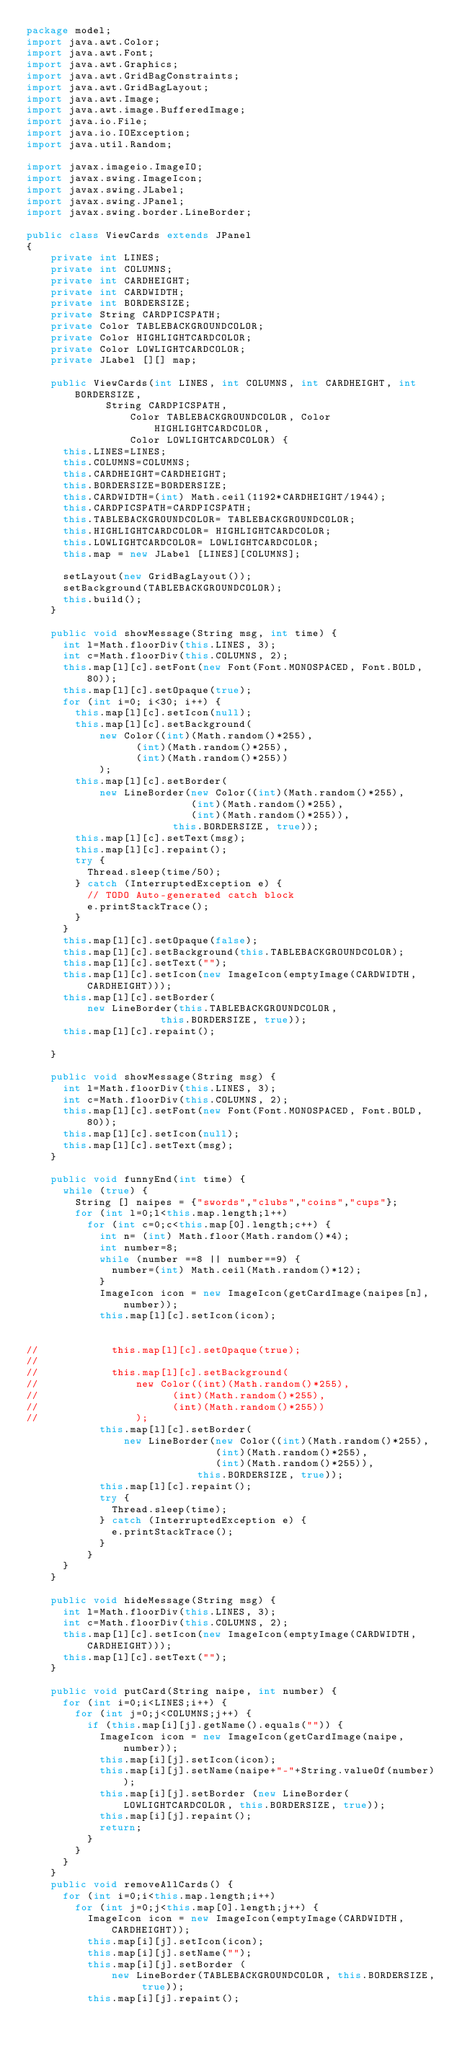Convert code to text. <code><loc_0><loc_0><loc_500><loc_500><_Java_>package model;
import java.awt.Color;
import java.awt.Font;
import java.awt.Graphics;
import java.awt.GridBagConstraints;
import java.awt.GridBagLayout;
import java.awt.Image;
import java.awt.image.BufferedImage;
import java.io.File;
import java.io.IOException;
import java.util.Random;

import javax.imageio.ImageIO;
import javax.swing.ImageIcon;
import javax.swing.JLabel;
import javax.swing.JPanel;
import javax.swing.border.LineBorder;

public class ViewCards extends JPanel 
{
		private int LINES;
		private int COLUMNS;
		private int CARDHEIGHT;
		private int CARDWIDTH;
		private int BORDERSIZE;
		private String CARDPICSPATH;
		private Color TABLEBACKGROUNDCOLOR;
		private Color HIGHLIGHTCARDCOLOR; 
		private Color LOWLIGHTCARDCOLOR;					
		private JLabel [][] map;
			
		public ViewCards(int LINES, int COLUMNS, int CARDHEIGHT, int BORDERSIZE,
						 String CARDPICSPATH,
				         Color TABLEBACKGROUNDCOLOR, Color HIGHLIGHTCARDCOLOR, 
				         Color LOWLIGHTCARDCOLOR) {
			this.LINES=LINES;
			this.COLUMNS=COLUMNS;
			this.CARDHEIGHT=CARDHEIGHT;
			this.BORDERSIZE=BORDERSIZE;
			this.CARDWIDTH=(int) Math.ceil(1192*CARDHEIGHT/1944);
			this.CARDPICSPATH=CARDPICSPATH;
			this.TABLEBACKGROUNDCOLOR= TABLEBACKGROUNDCOLOR;
			this.HIGHLIGHTCARDCOLOR= HIGHLIGHTCARDCOLOR; 
			this.LOWLIGHTCARDCOLOR= LOWLIGHTCARDCOLOR;					
			this.map = new JLabel [LINES][COLUMNS];
			
			setLayout(new GridBagLayout());
			setBackground(TABLEBACKGROUNDCOLOR);
			this.build();
		}	
		
		public void showMessage(String msg, int time) {
			int l=Math.floorDiv(this.LINES, 3);
			int c=Math.floorDiv(this.COLUMNS, 2);
			this.map[l][c].setFont(new Font(Font.MONOSPACED, Font.BOLD, 80));
			this.map[l][c].setOpaque(true);
			for (int i=0; i<30; i++) {
				this.map[l][c].setIcon(null);
				this.map[l][c].setBackground(
						new Color((int)(Math.random()*255),
								  (int)(Math.random()*255),
								  (int)(Math.random()*255))
						);
				this.map[l][c].setBorder(
						new LineBorder(new Color((int)(Math.random()*255),
								  				 (int)(Math.random()*255),
								  				 (int)(Math.random()*255)), 
								  	    this.BORDERSIZE, true));
				this.map[l][c].setText(msg);
				this.map[l][c].repaint();
				try {
					Thread.sleep(time/50);
				} catch (InterruptedException e) {
					// TODO Auto-generated catch block
					e.printStackTrace();
				}
			}
			this.map[l][c].setOpaque(false);
			this.map[l][c].setBackground(this.TABLEBACKGROUNDCOLOR);
			this.map[l][c].setText("");
			this.map[l][c].setIcon(new ImageIcon(emptyImage(CARDWIDTH, CARDHEIGHT)));
			this.map[l][c].setBorder(
					new LineBorder(this.TABLEBACKGROUNDCOLOR, 
							  	    this.BORDERSIZE, true));
			this.map[l][c].repaint();
			
		}
		
		public void showMessage(String msg) {
			int l=Math.floorDiv(this.LINES, 3);
			int c=Math.floorDiv(this.COLUMNS, 2);
			this.map[l][c].setFont(new Font(Font.MONOSPACED, Font.BOLD, 80));
			this.map[l][c].setIcon(null);			
			this.map[l][c].setText(msg);
		}
		
		public void funnyEnd(int time) {
			while (true) {
				String [] naipes = {"swords","clubs","coins","cups"};
				for (int l=0;l<this.map.length;l++)
					for (int c=0;c<this.map[0].length;c++) {
						int n= (int) Math.floor(Math.random()*4);
						int number=8;
						while (number ==8 || number==9) {
							number=(int) Math.ceil(Math.random()*12);
						}
						ImageIcon icon = new ImageIcon(getCardImage(naipes[n], number));
						this.map[l][c].setIcon(icon);
						
						
//						this.map[l][c].setOpaque(true);
//												
//						this.map[l][c].setBackground(
//								new Color((int)(Math.random()*255),
//										  (int)(Math.random()*255),
//										  (int)(Math.random()*255))
//								);
						this.map[l][c].setBorder(
								new LineBorder(new Color((int)(Math.random()*255),
										  				 (int)(Math.random()*255),
										  				 (int)(Math.random()*255)), 
										  	    this.BORDERSIZE, true));
						this.map[l][c].repaint();
						try {
							Thread.sleep(time);
						} catch (InterruptedException e) {
							e.printStackTrace();
						}
					}
			}
		}
		
		public void hideMessage(String msg) {
			int l=Math.floorDiv(this.LINES, 3);
			int c=Math.floorDiv(this.COLUMNS, 2);
			this.map[l][c].setIcon(new ImageIcon(emptyImage(CARDWIDTH,CARDHEIGHT)));
			this.map[l][c].setText("");
		}
		
		public void putCard(String naipe, int number) {
			for (int i=0;i<LINES;i++) {
				for (int j=0;j<COLUMNS;j++) {
					if (this.map[i][j].getName().equals("")) {
						ImageIcon icon = new ImageIcon(getCardImage(naipe, number));
						this.map[i][j].setIcon(icon);
						this.map[i][j].setName(naipe+"-"+String.valueOf(number));
						this.map[i][j].setBorder (new LineBorder(LOWLIGHTCARDCOLOR, this.BORDERSIZE, true));
						this.map[i][j].repaint();
						return;
					}
				}
			}
		}
		public void removeAllCards() {
			for (int i=0;i<this.map.length;i++)
				for (int j=0;j<this.map[0].length;j++) {
					ImageIcon icon = new ImageIcon(emptyImage(CARDWIDTH, CARDHEIGHT));
					this.map[i][j].setIcon(icon);
					this.map[i][j].setName("");
					this.map[i][j].setBorder (
							new LineBorder(TABLEBACKGROUNDCOLOR, this.BORDERSIZE, true));
					this.map[i][j].repaint();</code> 